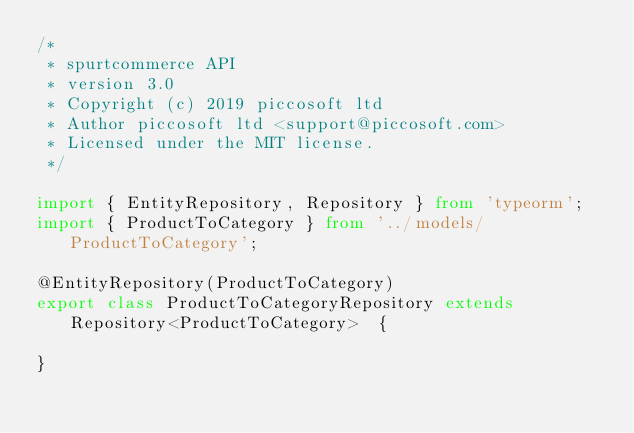<code> <loc_0><loc_0><loc_500><loc_500><_TypeScript_>/*
 * spurtcommerce API
 * version 3.0
 * Copyright (c) 2019 piccosoft ltd
 * Author piccosoft ltd <support@piccosoft.com>
 * Licensed under the MIT license.
 */

import { EntityRepository, Repository } from 'typeorm';
import { ProductToCategory } from '../models/ProductToCategory';

@EntityRepository(ProductToCategory)
export class ProductToCategoryRepository extends Repository<ProductToCategory>  {

}
</code> 